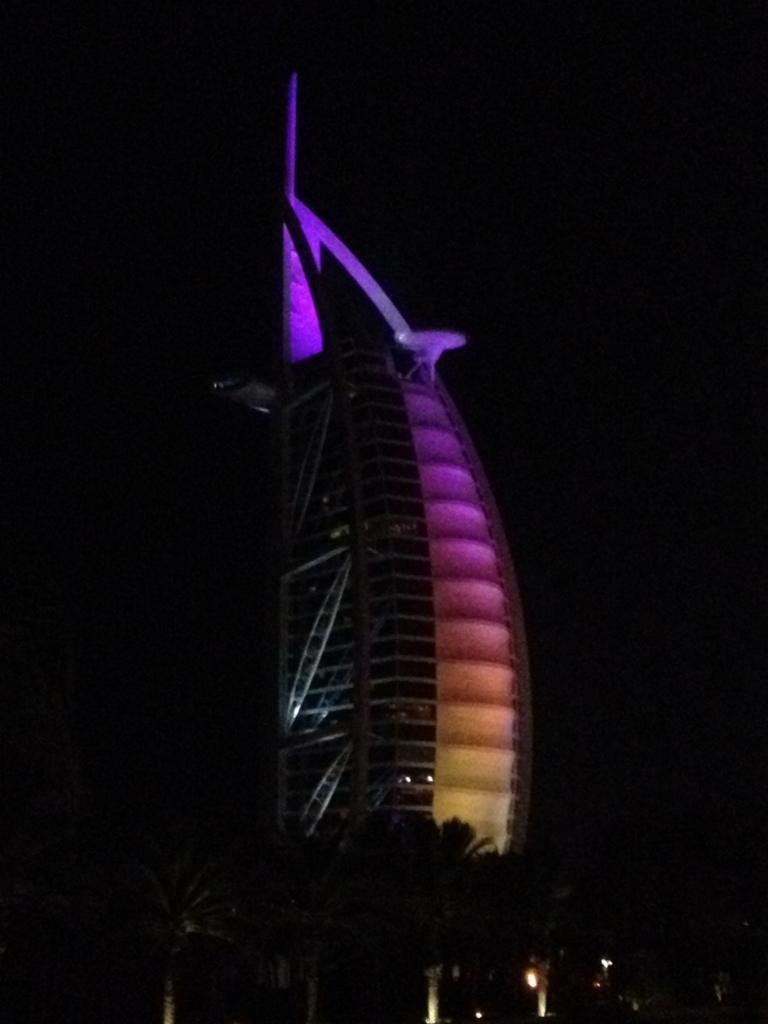What type of structure is present in the image? There is a building in the image. What type of vegetation is visible in the image? There are trees in the image. What type of illumination is present in the image? There are lights in the image. How would you describe the overall lighting condition in the image? The image is dark. Can you see any spoons being used by the bees in the image? There are no bees or spoons present in the image. Are the scissors being used to trim the trees in the image? There are no scissors or tree-trimming activity depicted in the image. 